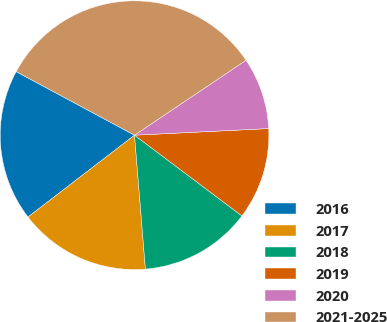Convert chart to OTSL. <chart><loc_0><loc_0><loc_500><loc_500><pie_chart><fcel>2016<fcel>2017<fcel>2018<fcel>2019<fcel>2020<fcel>2021-2025<nl><fcel>18.27%<fcel>15.86%<fcel>13.45%<fcel>11.04%<fcel>8.63%<fcel>32.73%<nl></chart> 